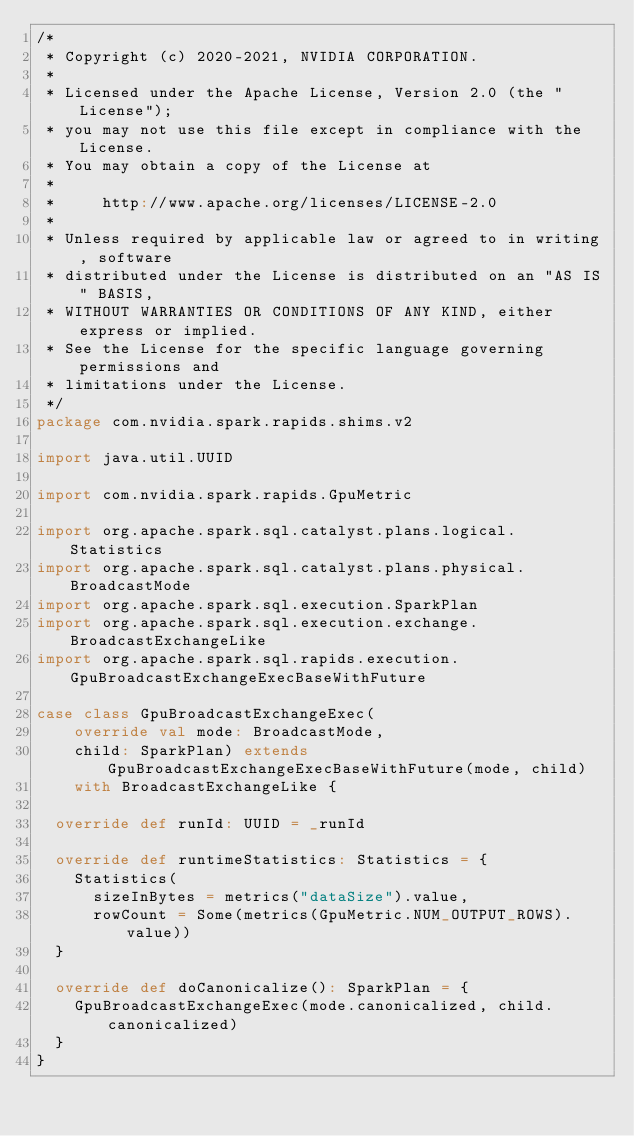Convert code to text. <code><loc_0><loc_0><loc_500><loc_500><_Scala_>/*
 * Copyright (c) 2020-2021, NVIDIA CORPORATION.
 *
 * Licensed under the Apache License, Version 2.0 (the "License");
 * you may not use this file except in compliance with the License.
 * You may obtain a copy of the License at
 *
 *     http://www.apache.org/licenses/LICENSE-2.0
 *
 * Unless required by applicable law or agreed to in writing, software
 * distributed under the License is distributed on an "AS IS" BASIS,
 * WITHOUT WARRANTIES OR CONDITIONS OF ANY KIND, either express or implied.
 * See the License for the specific language governing permissions and
 * limitations under the License.
 */
package com.nvidia.spark.rapids.shims.v2

import java.util.UUID

import com.nvidia.spark.rapids.GpuMetric

import org.apache.spark.sql.catalyst.plans.logical.Statistics
import org.apache.spark.sql.catalyst.plans.physical.BroadcastMode
import org.apache.spark.sql.execution.SparkPlan
import org.apache.spark.sql.execution.exchange.BroadcastExchangeLike
import org.apache.spark.sql.rapids.execution.GpuBroadcastExchangeExecBaseWithFuture

case class GpuBroadcastExchangeExec(
    override val mode: BroadcastMode,
    child: SparkPlan) extends GpuBroadcastExchangeExecBaseWithFuture(mode, child)
    with BroadcastExchangeLike {

  override def runId: UUID = _runId

  override def runtimeStatistics: Statistics = {
    Statistics(
      sizeInBytes = metrics("dataSize").value,
      rowCount = Some(metrics(GpuMetric.NUM_OUTPUT_ROWS).value))
  }

  override def doCanonicalize(): SparkPlan = {
    GpuBroadcastExchangeExec(mode.canonicalized, child.canonicalized)
  }
}
</code> 